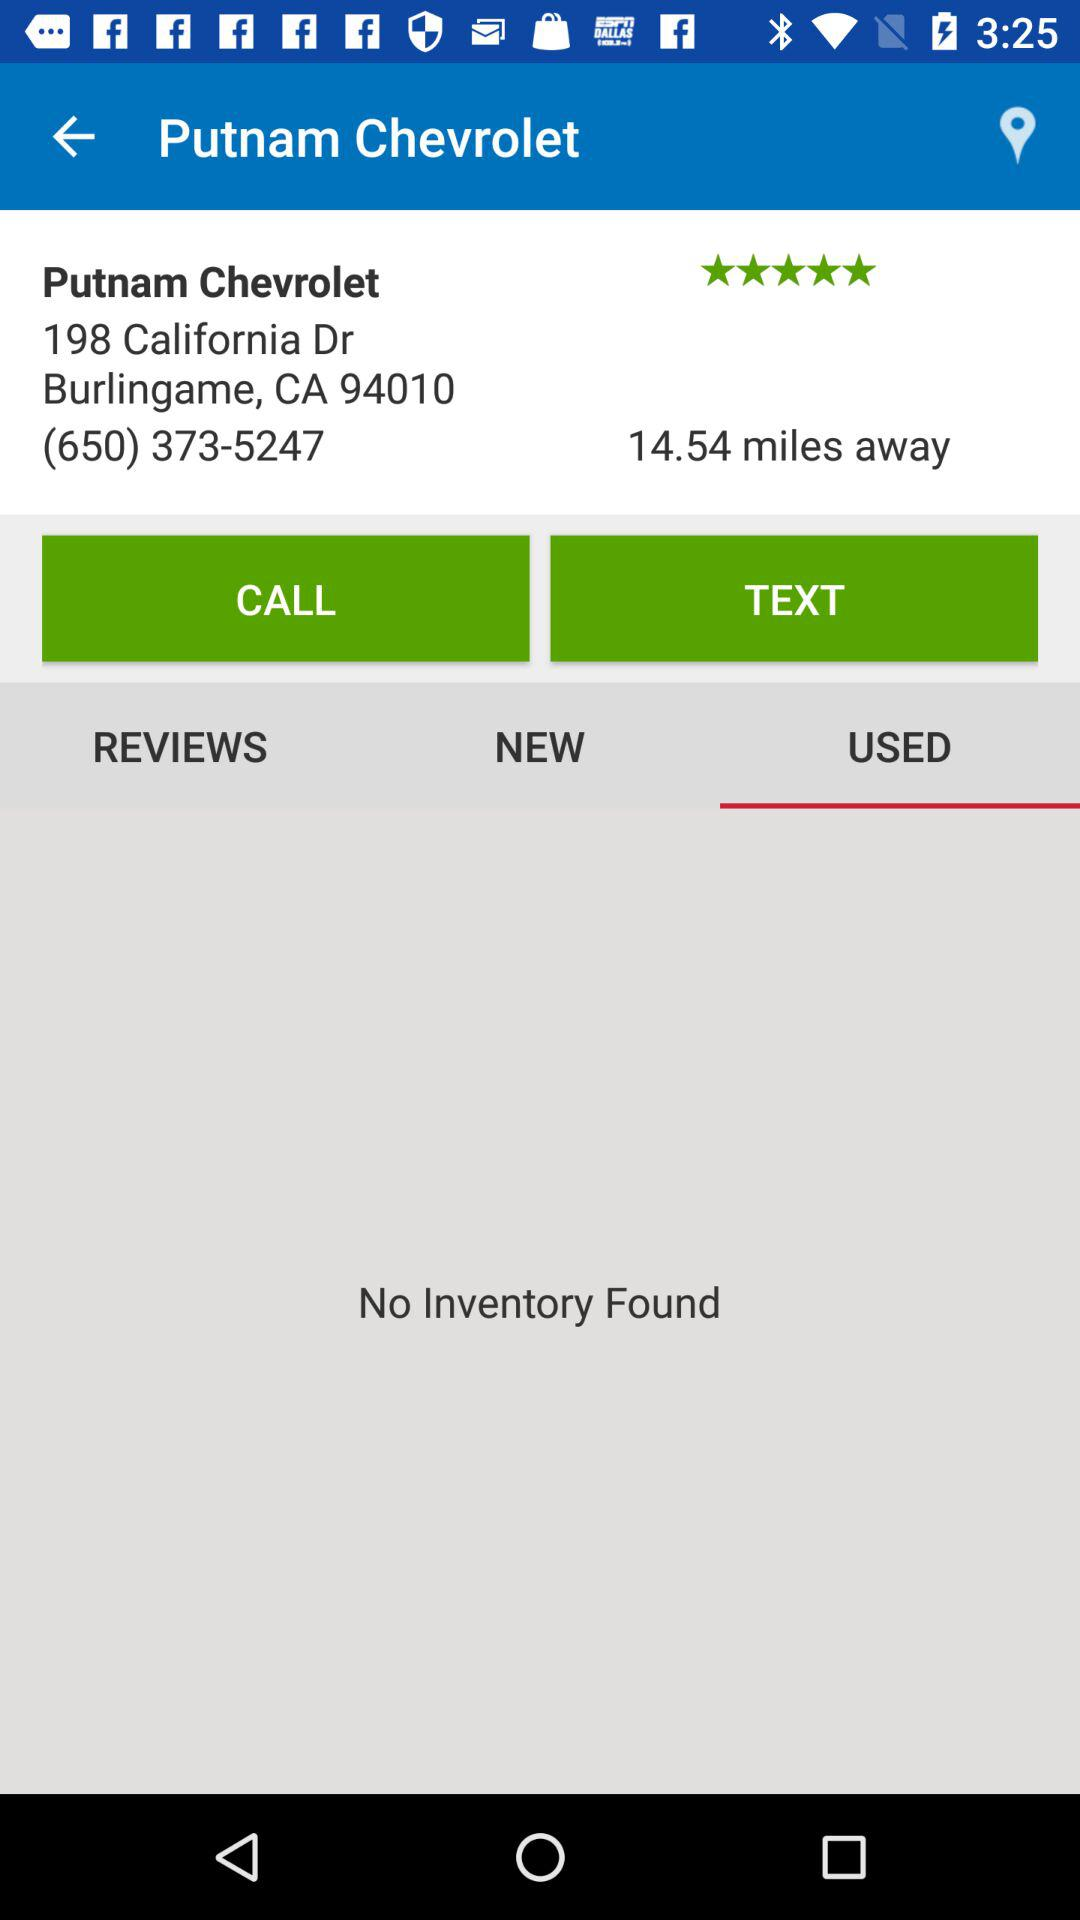What is the distance between "Putnam Chevrolet" and my location? The distance between "Putnam Chevrolet" and my location is 14.54 miles. 